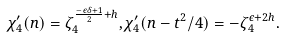Convert formula to latex. <formula><loc_0><loc_0><loc_500><loc_500>\chi _ { 4 } ^ { \prime } ( n ) = \zeta _ { 4 } ^ { \frac { - \epsilon \delta + 1 } { 2 } + h } , \chi _ { 4 } ^ { \prime } ( n - t ^ { 2 } / 4 ) = - \zeta _ { 4 } ^ { \epsilon + 2 h } .</formula> 